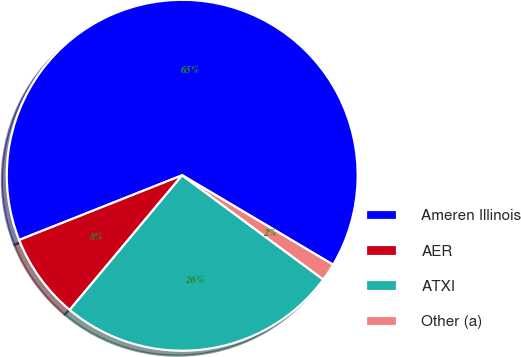Convert chart to OTSL. <chart><loc_0><loc_0><loc_500><loc_500><pie_chart><fcel>Ameren Illinois<fcel>AER<fcel>ATXI<fcel>Other (a)<nl><fcel>64.53%<fcel>7.91%<fcel>25.95%<fcel>1.61%<nl></chart> 